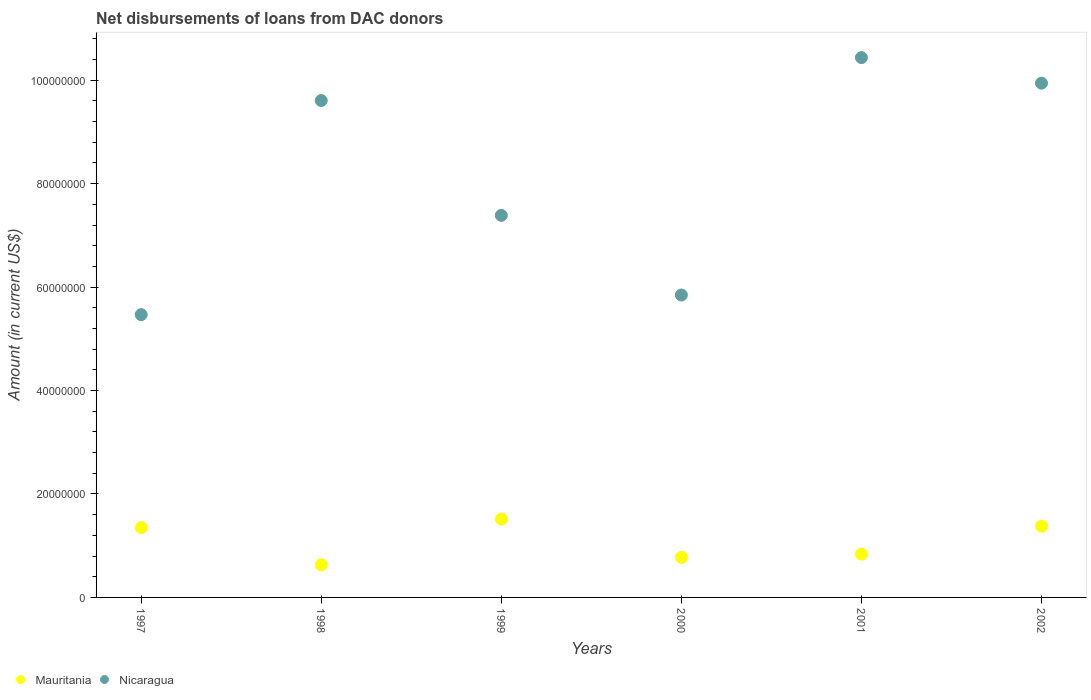How many different coloured dotlines are there?
Keep it short and to the point. 2. Is the number of dotlines equal to the number of legend labels?
Provide a succinct answer. Yes. What is the amount of loans disbursed in Mauritania in 1997?
Your answer should be compact. 1.35e+07. Across all years, what is the maximum amount of loans disbursed in Mauritania?
Keep it short and to the point. 1.52e+07. Across all years, what is the minimum amount of loans disbursed in Nicaragua?
Give a very brief answer. 5.47e+07. In which year was the amount of loans disbursed in Mauritania minimum?
Your answer should be very brief. 1998. What is the total amount of loans disbursed in Mauritania in the graph?
Make the answer very short. 6.49e+07. What is the difference between the amount of loans disbursed in Mauritania in 1998 and that in 2002?
Offer a terse response. -7.46e+06. What is the difference between the amount of loans disbursed in Mauritania in 1998 and the amount of loans disbursed in Nicaragua in 2000?
Give a very brief answer. -5.21e+07. What is the average amount of loans disbursed in Nicaragua per year?
Ensure brevity in your answer.  8.11e+07. In the year 1998, what is the difference between the amount of loans disbursed in Nicaragua and amount of loans disbursed in Mauritania?
Keep it short and to the point. 8.98e+07. In how many years, is the amount of loans disbursed in Nicaragua greater than 96000000 US$?
Your response must be concise. 3. What is the ratio of the amount of loans disbursed in Nicaragua in 1997 to that in 2001?
Give a very brief answer. 0.52. Is the amount of loans disbursed in Mauritania in 1997 less than that in 2000?
Offer a very short reply. No. What is the difference between the highest and the second highest amount of loans disbursed in Mauritania?
Offer a very short reply. 1.38e+06. What is the difference between the highest and the lowest amount of loans disbursed in Mauritania?
Make the answer very short. 8.84e+06. In how many years, is the amount of loans disbursed in Mauritania greater than the average amount of loans disbursed in Mauritania taken over all years?
Give a very brief answer. 3. Does the amount of loans disbursed in Nicaragua monotonically increase over the years?
Provide a succinct answer. No. Is the amount of loans disbursed in Nicaragua strictly less than the amount of loans disbursed in Mauritania over the years?
Provide a short and direct response. No. How many dotlines are there?
Give a very brief answer. 2. How many years are there in the graph?
Your answer should be compact. 6. Are the values on the major ticks of Y-axis written in scientific E-notation?
Ensure brevity in your answer.  No. How many legend labels are there?
Offer a terse response. 2. How are the legend labels stacked?
Offer a very short reply. Horizontal. What is the title of the graph?
Give a very brief answer. Net disbursements of loans from DAC donors. What is the label or title of the X-axis?
Offer a very short reply. Years. What is the Amount (in current US$) of Mauritania in 1997?
Provide a succinct answer. 1.35e+07. What is the Amount (in current US$) of Nicaragua in 1997?
Offer a very short reply. 5.47e+07. What is the Amount (in current US$) of Mauritania in 1998?
Provide a succinct answer. 6.31e+06. What is the Amount (in current US$) in Nicaragua in 1998?
Make the answer very short. 9.61e+07. What is the Amount (in current US$) in Mauritania in 1999?
Provide a succinct answer. 1.52e+07. What is the Amount (in current US$) in Nicaragua in 1999?
Provide a succinct answer. 7.39e+07. What is the Amount (in current US$) of Mauritania in 2000?
Provide a short and direct response. 7.75e+06. What is the Amount (in current US$) in Nicaragua in 2000?
Provide a succinct answer. 5.85e+07. What is the Amount (in current US$) in Mauritania in 2001?
Make the answer very short. 8.37e+06. What is the Amount (in current US$) in Nicaragua in 2001?
Keep it short and to the point. 1.04e+08. What is the Amount (in current US$) in Mauritania in 2002?
Offer a very short reply. 1.38e+07. What is the Amount (in current US$) in Nicaragua in 2002?
Keep it short and to the point. 9.94e+07. Across all years, what is the maximum Amount (in current US$) in Mauritania?
Your response must be concise. 1.52e+07. Across all years, what is the maximum Amount (in current US$) of Nicaragua?
Your answer should be very brief. 1.04e+08. Across all years, what is the minimum Amount (in current US$) of Mauritania?
Offer a terse response. 6.31e+06. Across all years, what is the minimum Amount (in current US$) in Nicaragua?
Make the answer very short. 5.47e+07. What is the total Amount (in current US$) in Mauritania in the graph?
Your answer should be very brief. 6.49e+07. What is the total Amount (in current US$) of Nicaragua in the graph?
Your answer should be compact. 4.87e+08. What is the difference between the Amount (in current US$) of Mauritania in 1997 and that in 1998?
Your answer should be very brief. 7.19e+06. What is the difference between the Amount (in current US$) of Nicaragua in 1997 and that in 1998?
Offer a terse response. -4.14e+07. What is the difference between the Amount (in current US$) in Mauritania in 1997 and that in 1999?
Provide a short and direct response. -1.65e+06. What is the difference between the Amount (in current US$) of Nicaragua in 1997 and that in 1999?
Provide a succinct answer. -1.92e+07. What is the difference between the Amount (in current US$) in Mauritania in 1997 and that in 2000?
Make the answer very short. 5.76e+06. What is the difference between the Amount (in current US$) of Nicaragua in 1997 and that in 2000?
Give a very brief answer. -3.79e+06. What is the difference between the Amount (in current US$) of Mauritania in 1997 and that in 2001?
Offer a terse response. 5.14e+06. What is the difference between the Amount (in current US$) in Nicaragua in 1997 and that in 2001?
Give a very brief answer. -4.97e+07. What is the difference between the Amount (in current US$) of Mauritania in 1997 and that in 2002?
Provide a succinct answer. -2.70e+05. What is the difference between the Amount (in current US$) of Nicaragua in 1997 and that in 2002?
Make the answer very short. -4.47e+07. What is the difference between the Amount (in current US$) of Mauritania in 1998 and that in 1999?
Give a very brief answer. -8.84e+06. What is the difference between the Amount (in current US$) of Nicaragua in 1998 and that in 1999?
Keep it short and to the point. 2.22e+07. What is the difference between the Amount (in current US$) of Mauritania in 1998 and that in 2000?
Your answer should be very brief. -1.44e+06. What is the difference between the Amount (in current US$) in Nicaragua in 1998 and that in 2000?
Provide a succinct answer. 3.76e+07. What is the difference between the Amount (in current US$) in Mauritania in 1998 and that in 2001?
Provide a succinct answer. -2.06e+06. What is the difference between the Amount (in current US$) in Nicaragua in 1998 and that in 2001?
Make the answer very short. -8.30e+06. What is the difference between the Amount (in current US$) in Mauritania in 1998 and that in 2002?
Keep it short and to the point. -7.46e+06. What is the difference between the Amount (in current US$) of Nicaragua in 1998 and that in 2002?
Offer a very short reply. -3.36e+06. What is the difference between the Amount (in current US$) of Mauritania in 1999 and that in 2000?
Provide a succinct answer. 7.40e+06. What is the difference between the Amount (in current US$) in Nicaragua in 1999 and that in 2000?
Ensure brevity in your answer.  1.54e+07. What is the difference between the Amount (in current US$) of Mauritania in 1999 and that in 2001?
Your answer should be compact. 6.78e+06. What is the difference between the Amount (in current US$) of Nicaragua in 1999 and that in 2001?
Your answer should be compact. -3.05e+07. What is the difference between the Amount (in current US$) of Mauritania in 1999 and that in 2002?
Your answer should be compact. 1.38e+06. What is the difference between the Amount (in current US$) in Nicaragua in 1999 and that in 2002?
Your response must be concise. -2.56e+07. What is the difference between the Amount (in current US$) in Mauritania in 2000 and that in 2001?
Give a very brief answer. -6.21e+05. What is the difference between the Amount (in current US$) in Nicaragua in 2000 and that in 2001?
Your answer should be very brief. -4.59e+07. What is the difference between the Amount (in current US$) of Mauritania in 2000 and that in 2002?
Provide a succinct answer. -6.03e+06. What is the difference between the Amount (in current US$) in Nicaragua in 2000 and that in 2002?
Keep it short and to the point. -4.10e+07. What is the difference between the Amount (in current US$) of Mauritania in 2001 and that in 2002?
Your answer should be very brief. -5.41e+06. What is the difference between the Amount (in current US$) in Nicaragua in 2001 and that in 2002?
Make the answer very short. 4.94e+06. What is the difference between the Amount (in current US$) of Mauritania in 1997 and the Amount (in current US$) of Nicaragua in 1998?
Give a very brief answer. -8.26e+07. What is the difference between the Amount (in current US$) in Mauritania in 1997 and the Amount (in current US$) in Nicaragua in 1999?
Keep it short and to the point. -6.04e+07. What is the difference between the Amount (in current US$) in Mauritania in 1997 and the Amount (in current US$) in Nicaragua in 2000?
Keep it short and to the point. -4.50e+07. What is the difference between the Amount (in current US$) of Mauritania in 1997 and the Amount (in current US$) of Nicaragua in 2001?
Offer a terse response. -9.09e+07. What is the difference between the Amount (in current US$) in Mauritania in 1997 and the Amount (in current US$) in Nicaragua in 2002?
Offer a terse response. -8.59e+07. What is the difference between the Amount (in current US$) in Mauritania in 1998 and the Amount (in current US$) in Nicaragua in 1999?
Your answer should be very brief. -6.75e+07. What is the difference between the Amount (in current US$) of Mauritania in 1998 and the Amount (in current US$) of Nicaragua in 2000?
Your response must be concise. -5.21e+07. What is the difference between the Amount (in current US$) in Mauritania in 1998 and the Amount (in current US$) in Nicaragua in 2001?
Your answer should be very brief. -9.80e+07. What is the difference between the Amount (in current US$) in Mauritania in 1998 and the Amount (in current US$) in Nicaragua in 2002?
Offer a very short reply. -9.31e+07. What is the difference between the Amount (in current US$) in Mauritania in 1999 and the Amount (in current US$) in Nicaragua in 2000?
Offer a very short reply. -4.33e+07. What is the difference between the Amount (in current US$) in Mauritania in 1999 and the Amount (in current US$) in Nicaragua in 2001?
Provide a short and direct response. -8.92e+07. What is the difference between the Amount (in current US$) of Mauritania in 1999 and the Amount (in current US$) of Nicaragua in 2002?
Make the answer very short. -8.43e+07. What is the difference between the Amount (in current US$) of Mauritania in 2000 and the Amount (in current US$) of Nicaragua in 2001?
Make the answer very short. -9.66e+07. What is the difference between the Amount (in current US$) of Mauritania in 2000 and the Amount (in current US$) of Nicaragua in 2002?
Give a very brief answer. -9.17e+07. What is the difference between the Amount (in current US$) in Mauritania in 2001 and the Amount (in current US$) in Nicaragua in 2002?
Your answer should be compact. -9.11e+07. What is the average Amount (in current US$) of Mauritania per year?
Your answer should be very brief. 1.08e+07. What is the average Amount (in current US$) of Nicaragua per year?
Your answer should be very brief. 8.11e+07. In the year 1997, what is the difference between the Amount (in current US$) in Mauritania and Amount (in current US$) in Nicaragua?
Provide a short and direct response. -4.12e+07. In the year 1998, what is the difference between the Amount (in current US$) of Mauritania and Amount (in current US$) of Nicaragua?
Your answer should be very brief. -8.98e+07. In the year 1999, what is the difference between the Amount (in current US$) in Mauritania and Amount (in current US$) in Nicaragua?
Make the answer very short. -5.87e+07. In the year 2000, what is the difference between the Amount (in current US$) in Mauritania and Amount (in current US$) in Nicaragua?
Your answer should be very brief. -5.07e+07. In the year 2001, what is the difference between the Amount (in current US$) of Mauritania and Amount (in current US$) of Nicaragua?
Give a very brief answer. -9.60e+07. In the year 2002, what is the difference between the Amount (in current US$) of Mauritania and Amount (in current US$) of Nicaragua?
Provide a short and direct response. -8.56e+07. What is the ratio of the Amount (in current US$) of Mauritania in 1997 to that in 1998?
Ensure brevity in your answer.  2.14. What is the ratio of the Amount (in current US$) in Nicaragua in 1997 to that in 1998?
Give a very brief answer. 0.57. What is the ratio of the Amount (in current US$) in Mauritania in 1997 to that in 1999?
Your response must be concise. 0.89. What is the ratio of the Amount (in current US$) of Nicaragua in 1997 to that in 1999?
Your response must be concise. 0.74. What is the ratio of the Amount (in current US$) of Mauritania in 1997 to that in 2000?
Give a very brief answer. 1.74. What is the ratio of the Amount (in current US$) of Nicaragua in 1997 to that in 2000?
Make the answer very short. 0.94. What is the ratio of the Amount (in current US$) in Mauritania in 1997 to that in 2001?
Give a very brief answer. 1.61. What is the ratio of the Amount (in current US$) in Nicaragua in 1997 to that in 2001?
Make the answer very short. 0.52. What is the ratio of the Amount (in current US$) of Mauritania in 1997 to that in 2002?
Keep it short and to the point. 0.98. What is the ratio of the Amount (in current US$) in Nicaragua in 1997 to that in 2002?
Keep it short and to the point. 0.55. What is the ratio of the Amount (in current US$) of Mauritania in 1998 to that in 1999?
Keep it short and to the point. 0.42. What is the ratio of the Amount (in current US$) in Nicaragua in 1998 to that in 1999?
Offer a very short reply. 1.3. What is the ratio of the Amount (in current US$) in Mauritania in 1998 to that in 2000?
Your answer should be compact. 0.81. What is the ratio of the Amount (in current US$) of Nicaragua in 1998 to that in 2000?
Provide a succinct answer. 1.64. What is the ratio of the Amount (in current US$) in Mauritania in 1998 to that in 2001?
Offer a terse response. 0.75. What is the ratio of the Amount (in current US$) in Nicaragua in 1998 to that in 2001?
Your answer should be compact. 0.92. What is the ratio of the Amount (in current US$) in Mauritania in 1998 to that in 2002?
Your answer should be very brief. 0.46. What is the ratio of the Amount (in current US$) in Nicaragua in 1998 to that in 2002?
Offer a terse response. 0.97. What is the ratio of the Amount (in current US$) of Mauritania in 1999 to that in 2000?
Give a very brief answer. 1.96. What is the ratio of the Amount (in current US$) in Nicaragua in 1999 to that in 2000?
Provide a succinct answer. 1.26. What is the ratio of the Amount (in current US$) in Mauritania in 1999 to that in 2001?
Ensure brevity in your answer.  1.81. What is the ratio of the Amount (in current US$) in Nicaragua in 1999 to that in 2001?
Keep it short and to the point. 0.71. What is the ratio of the Amount (in current US$) in Mauritania in 1999 to that in 2002?
Provide a succinct answer. 1.1. What is the ratio of the Amount (in current US$) of Nicaragua in 1999 to that in 2002?
Offer a terse response. 0.74. What is the ratio of the Amount (in current US$) in Mauritania in 2000 to that in 2001?
Provide a succinct answer. 0.93. What is the ratio of the Amount (in current US$) in Nicaragua in 2000 to that in 2001?
Your response must be concise. 0.56. What is the ratio of the Amount (in current US$) of Mauritania in 2000 to that in 2002?
Your answer should be very brief. 0.56. What is the ratio of the Amount (in current US$) in Nicaragua in 2000 to that in 2002?
Your answer should be compact. 0.59. What is the ratio of the Amount (in current US$) of Mauritania in 2001 to that in 2002?
Offer a terse response. 0.61. What is the ratio of the Amount (in current US$) of Nicaragua in 2001 to that in 2002?
Your answer should be very brief. 1.05. What is the difference between the highest and the second highest Amount (in current US$) of Mauritania?
Offer a very short reply. 1.38e+06. What is the difference between the highest and the second highest Amount (in current US$) of Nicaragua?
Your answer should be compact. 4.94e+06. What is the difference between the highest and the lowest Amount (in current US$) of Mauritania?
Keep it short and to the point. 8.84e+06. What is the difference between the highest and the lowest Amount (in current US$) of Nicaragua?
Your answer should be very brief. 4.97e+07. 